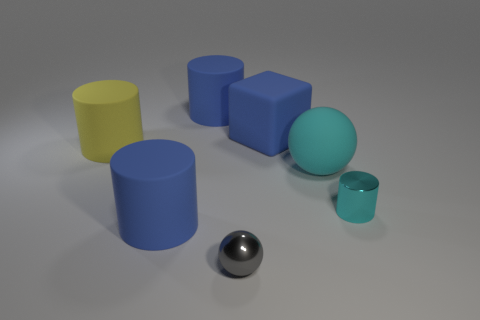There is another shiny thing that is the same shape as the big cyan object; what size is it?
Provide a succinct answer. Small. Does the small gray object have the same shape as the large blue object in front of the yellow cylinder?
Offer a terse response. No. There is a cyan object to the left of the metallic cylinder; does it have the same shape as the yellow rubber object?
Offer a very short reply. No. How many big blue things are both behind the cyan rubber ball and in front of the large sphere?
Provide a succinct answer. 0. How many other objects are the same size as the gray sphere?
Give a very brief answer. 1. Are there the same number of blue rubber things on the right side of the gray thing and yellow things?
Provide a short and direct response. Yes. Is the color of the large matte cylinder that is behind the yellow matte thing the same as the large cylinder that is in front of the large yellow cylinder?
Offer a terse response. Yes. What material is the object that is both in front of the small cyan metal object and to the left of the gray ball?
Offer a terse response. Rubber. What color is the metal cylinder?
Provide a succinct answer. Cyan. What number of other things are there of the same shape as the large yellow matte object?
Your answer should be compact. 3. 